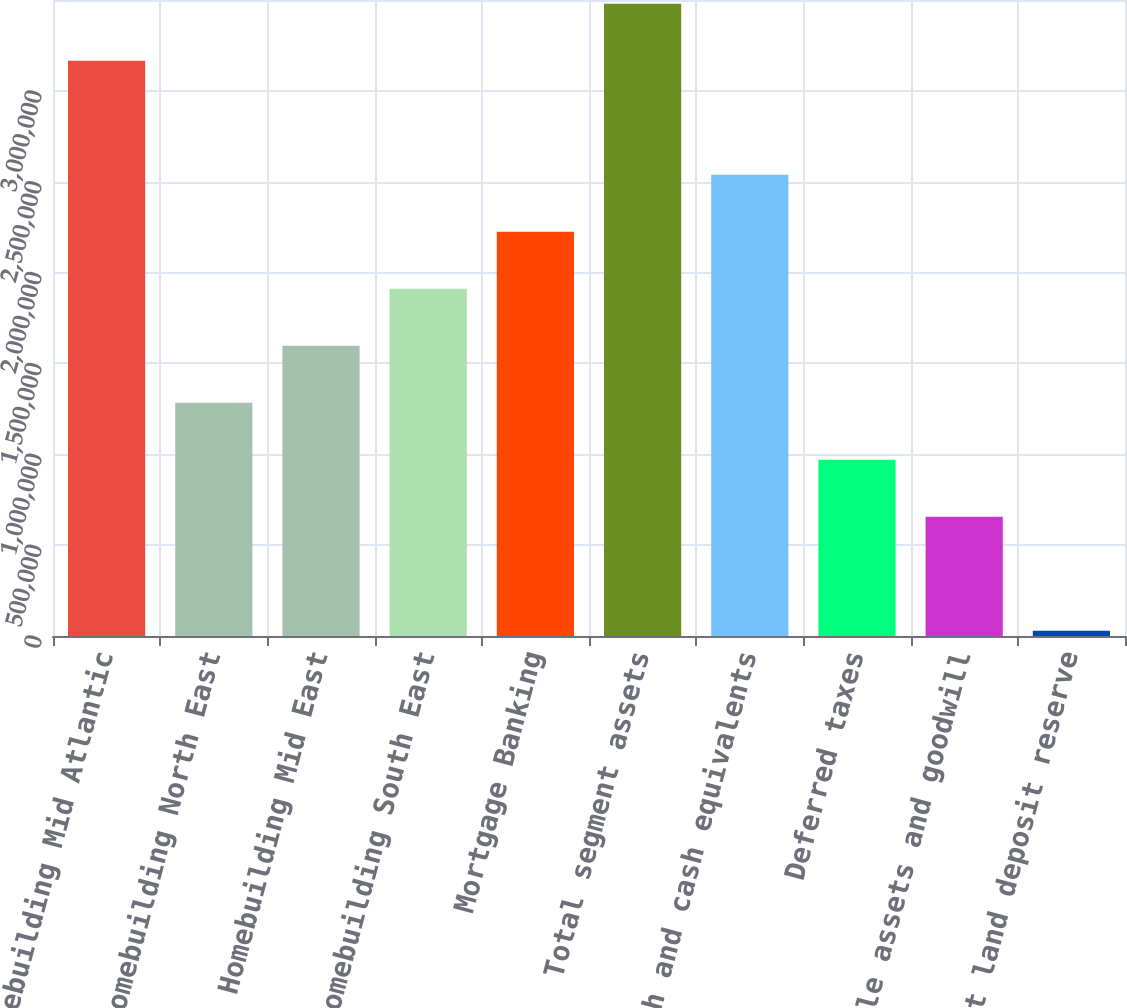<chart> <loc_0><loc_0><loc_500><loc_500><bar_chart><fcel>Homebuilding Mid Atlantic<fcel>Homebuilding North East<fcel>Homebuilding Mid East<fcel>Homebuilding South East<fcel>Mortgage Banking<fcel>Total segment assets<fcel>Cash and cash equivalents<fcel>Deferred taxes<fcel>Intangible assets and goodwill<fcel>Contract land deposit reserve<nl><fcel>3.16593e+06<fcel>1.2839e+06<fcel>1.59757e+06<fcel>1.91125e+06<fcel>2.22492e+06<fcel>3.4796e+06<fcel>2.53859e+06<fcel>970231<fcel>656559<fcel>29216<nl></chart> 